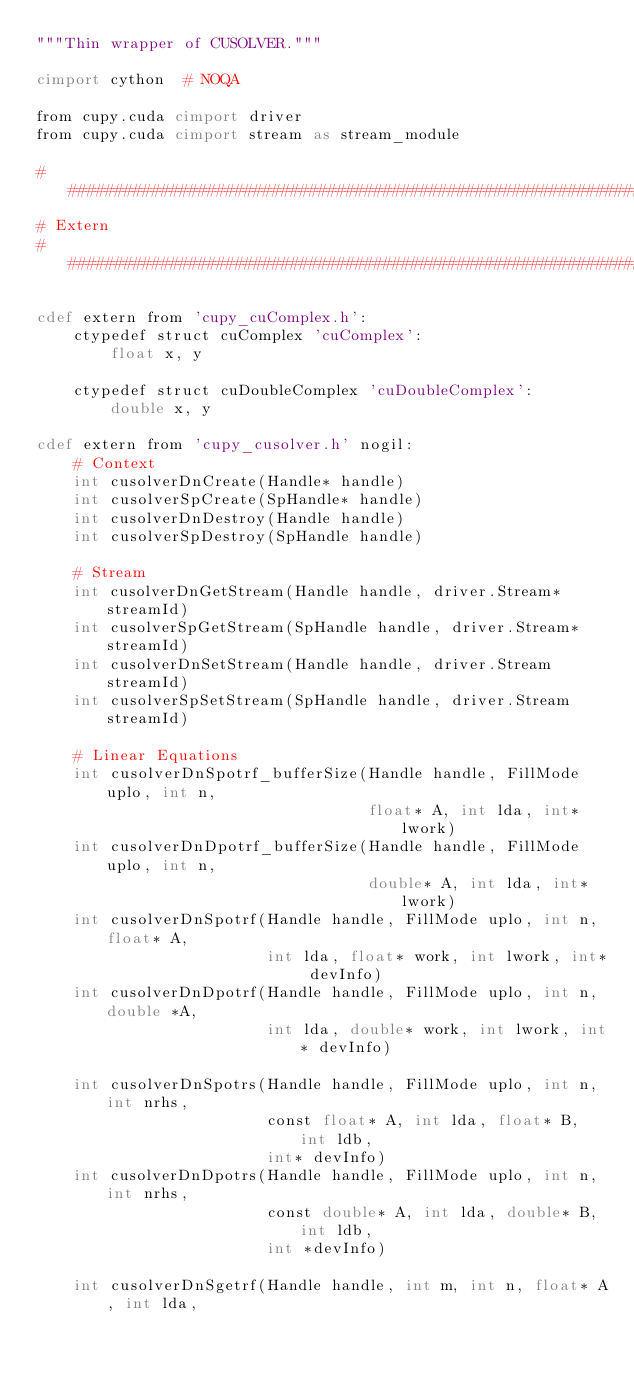Convert code to text. <code><loc_0><loc_0><loc_500><loc_500><_Cython_>"""Thin wrapper of CUSOLVER."""

cimport cython  # NOQA

from cupy.cuda cimport driver
from cupy.cuda cimport stream as stream_module

###############################################################################
# Extern
###############################################################################

cdef extern from 'cupy_cuComplex.h':
    ctypedef struct cuComplex 'cuComplex':
        float x, y

    ctypedef struct cuDoubleComplex 'cuDoubleComplex':
        double x, y

cdef extern from 'cupy_cusolver.h' nogil:
    # Context
    int cusolverDnCreate(Handle* handle)
    int cusolverSpCreate(SpHandle* handle)
    int cusolverDnDestroy(Handle handle)
    int cusolverSpDestroy(SpHandle handle)

    # Stream
    int cusolverDnGetStream(Handle handle, driver.Stream* streamId)
    int cusolverSpGetStream(SpHandle handle, driver.Stream* streamId)
    int cusolverDnSetStream(Handle handle, driver.Stream streamId)
    int cusolverSpSetStream(SpHandle handle, driver.Stream streamId)

    # Linear Equations
    int cusolverDnSpotrf_bufferSize(Handle handle, FillMode uplo, int n,
                                    float* A, int lda, int* lwork)
    int cusolverDnDpotrf_bufferSize(Handle handle, FillMode uplo, int n,
                                    double* A, int lda, int* lwork)
    int cusolverDnSpotrf(Handle handle, FillMode uplo, int n, float* A,
                         int lda, float* work, int lwork, int* devInfo)
    int cusolverDnDpotrf(Handle handle, FillMode uplo, int n, double *A,
                         int lda, double* work, int lwork, int* devInfo)

    int cusolverDnSpotrs(Handle handle, FillMode uplo, int n, int nrhs,
                         const float* A, int lda, float* B, int ldb,
                         int* devInfo)
    int cusolverDnDpotrs(Handle handle, FillMode uplo, int n, int nrhs,
                         const double* A, int lda, double* B, int ldb,
                         int *devInfo)

    int cusolverDnSgetrf(Handle handle, int m, int n, float* A, int lda,</code> 